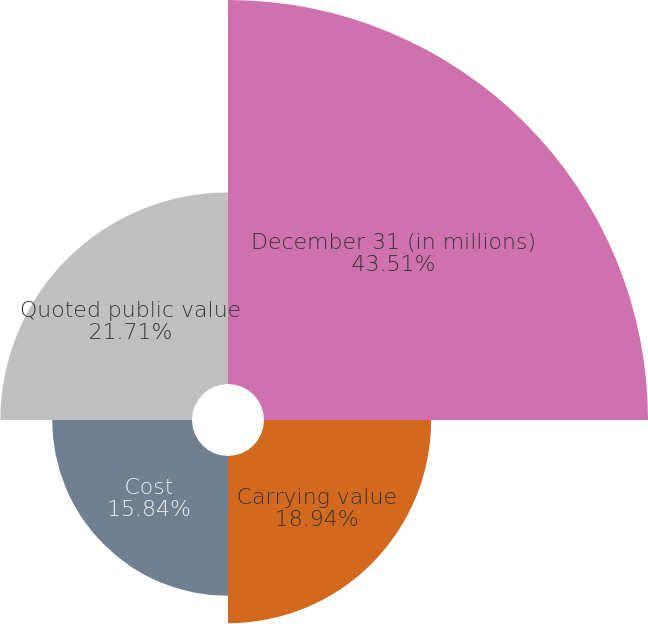Convert chart to OTSL. <chart><loc_0><loc_0><loc_500><loc_500><pie_chart><fcel>December 31 (in millions)<fcel>Carrying value<fcel>Cost<fcel>Quoted public value<nl><fcel>43.51%<fcel>18.94%<fcel>15.84%<fcel>21.71%<nl></chart> 